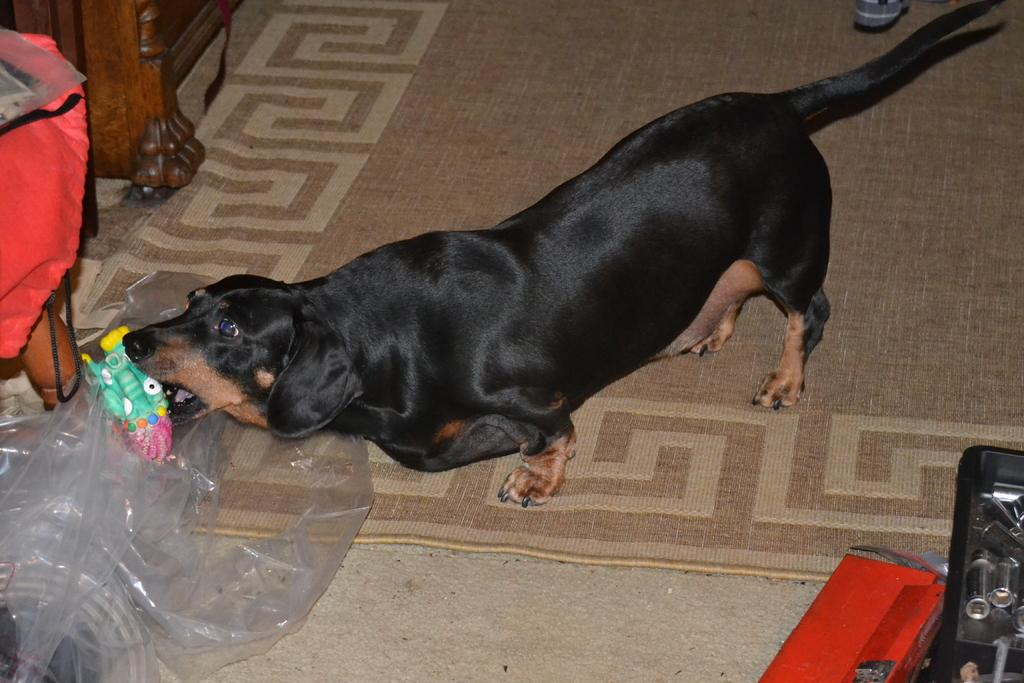What type of animal is in the image? There is a black dog in the image. Where is the dog located in the image? The dog is on the floor. What can be seen on the left side of the image? There is a polythene cover on the left side of the image. What type of family can be seen playing in the playground in the image? There is no family or playground present in the image; it features a black dog on the floor and a polythene cover on the left side. 